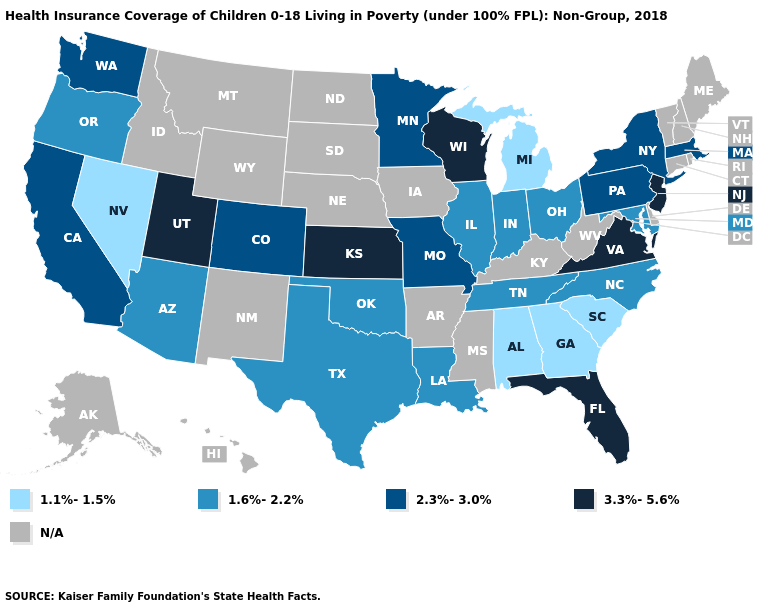Which states have the lowest value in the Northeast?
Concise answer only. Massachusetts, New York, Pennsylvania. Which states have the lowest value in the West?
Quick response, please. Nevada. Name the states that have a value in the range 1.6%-2.2%?
Quick response, please. Arizona, Illinois, Indiana, Louisiana, Maryland, North Carolina, Ohio, Oklahoma, Oregon, Tennessee, Texas. Name the states that have a value in the range 2.3%-3.0%?
Concise answer only. California, Colorado, Massachusetts, Minnesota, Missouri, New York, Pennsylvania, Washington. What is the highest value in the USA?
Give a very brief answer. 3.3%-5.6%. How many symbols are there in the legend?
Quick response, please. 5. Name the states that have a value in the range 3.3%-5.6%?
Quick response, please. Florida, Kansas, New Jersey, Utah, Virginia, Wisconsin. What is the highest value in states that border New York?
Quick response, please. 3.3%-5.6%. Which states have the highest value in the USA?
Short answer required. Florida, Kansas, New Jersey, Utah, Virginia, Wisconsin. What is the value of Alabama?
Concise answer only. 1.1%-1.5%. Does Florida have the highest value in the South?
Short answer required. Yes. 